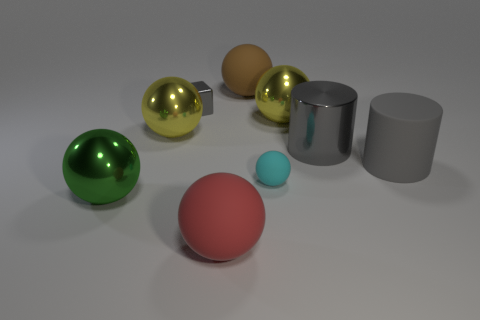Subtract all red rubber spheres. How many spheres are left? 5 Subtract all blue cylinders. How many yellow balls are left? 2 Add 1 big gray rubber things. How many objects exist? 10 Subtract all green spheres. How many spheres are left? 5 Subtract all large green objects. Subtract all shiny cubes. How many objects are left? 7 Add 2 metallic cylinders. How many metallic cylinders are left? 3 Add 6 large red objects. How many large red objects exist? 7 Subtract 0 cyan cubes. How many objects are left? 9 Subtract all cylinders. How many objects are left? 7 Subtract 2 spheres. How many spheres are left? 4 